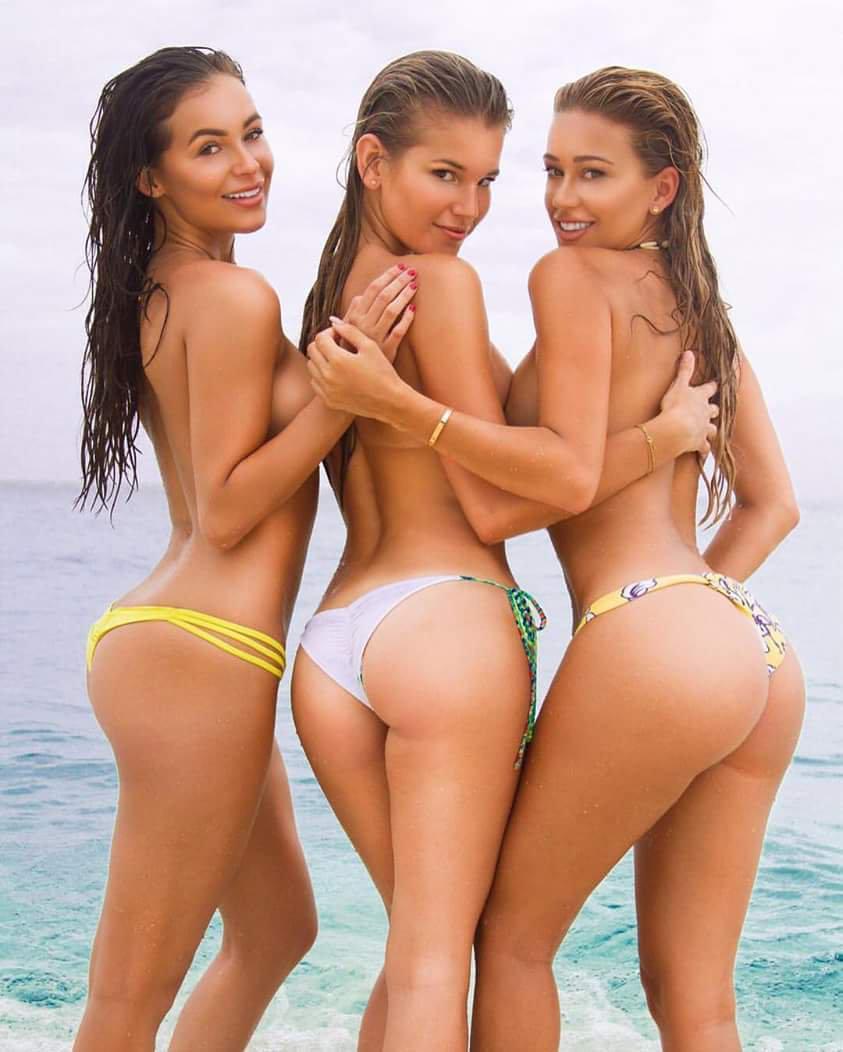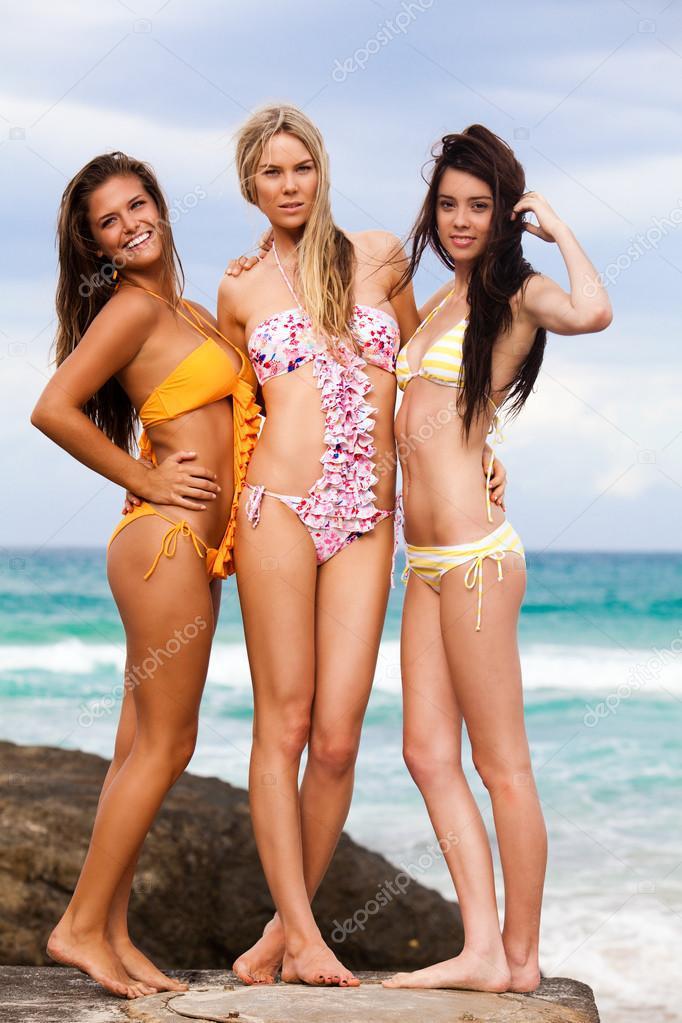The first image is the image on the left, the second image is the image on the right. Examine the images to the left and right. Is the description "The three women in bikinis in the image on the right are shown from behind." accurate? Answer yes or no. No. The first image is the image on the left, the second image is the image on the right. Given the left and right images, does the statement "An image shows three bikini models with their rears to the camera, standing with arms around each other." hold true? Answer yes or no. Yes. 